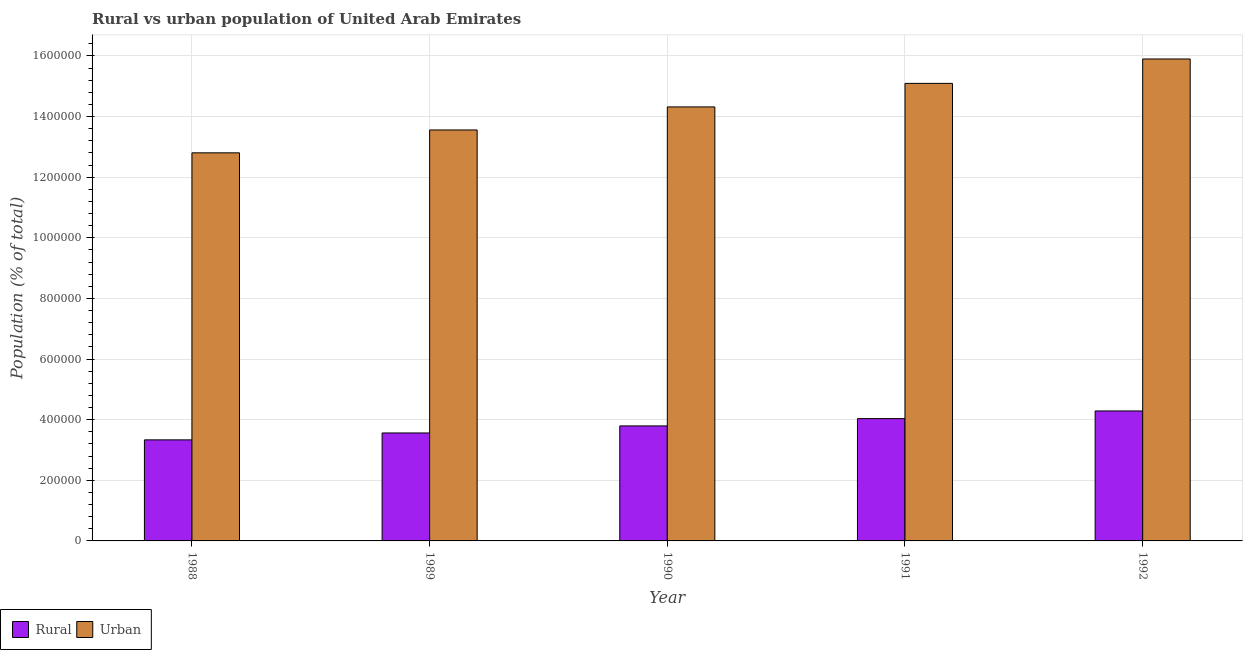How many groups of bars are there?
Ensure brevity in your answer.  5. What is the label of the 5th group of bars from the left?
Your answer should be very brief. 1992. What is the rural population density in 1989?
Keep it short and to the point. 3.56e+05. Across all years, what is the maximum urban population density?
Make the answer very short. 1.59e+06. Across all years, what is the minimum urban population density?
Your answer should be compact. 1.28e+06. In which year was the rural population density maximum?
Give a very brief answer. 1992. In which year was the urban population density minimum?
Make the answer very short. 1988. What is the total rural population density in the graph?
Make the answer very short. 1.90e+06. What is the difference between the urban population density in 1988 and that in 1991?
Provide a short and direct response. -2.29e+05. What is the difference between the urban population density in 1992 and the rural population density in 1989?
Your response must be concise. 2.34e+05. What is the average urban population density per year?
Provide a succinct answer. 1.43e+06. In the year 1991, what is the difference between the urban population density and rural population density?
Your answer should be compact. 0. In how many years, is the rural population density greater than 1480000 %?
Give a very brief answer. 0. What is the ratio of the urban population density in 1989 to that in 1992?
Provide a succinct answer. 0.85. Is the urban population density in 1988 less than that in 1992?
Ensure brevity in your answer.  Yes. What is the difference between the highest and the second highest rural population density?
Offer a terse response. 2.53e+04. What is the difference between the highest and the lowest rural population density?
Offer a terse response. 9.54e+04. What does the 2nd bar from the left in 1991 represents?
Provide a succinct answer. Urban. What does the 2nd bar from the right in 1990 represents?
Your answer should be very brief. Rural. How many bars are there?
Your response must be concise. 10. Does the graph contain grids?
Offer a terse response. Yes. Where does the legend appear in the graph?
Give a very brief answer. Bottom left. How many legend labels are there?
Offer a very short reply. 2. How are the legend labels stacked?
Offer a very short reply. Horizontal. What is the title of the graph?
Give a very brief answer. Rural vs urban population of United Arab Emirates. What is the label or title of the Y-axis?
Provide a short and direct response. Population (% of total). What is the Population (% of total) of Rural in 1988?
Ensure brevity in your answer.  3.33e+05. What is the Population (% of total) of Urban in 1988?
Keep it short and to the point. 1.28e+06. What is the Population (% of total) in Rural in 1989?
Your answer should be compact. 3.56e+05. What is the Population (% of total) of Urban in 1989?
Give a very brief answer. 1.36e+06. What is the Population (% of total) of Rural in 1990?
Offer a very short reply. 3.79e+05. What is the Population (% of total) in Urban in 1990?
Offer a terse response. 1.43e+06. What is the Population (% of total) in Rural in 1991?
Offer a terse response. 4.04e+05. What is the Population (% of total) in Urban in 1991?
Your answer should be compact. 1.51e+06. What is the Population (% of total) of Rural in 1992?
Keep it short and to the point. 4.29e+05. What is the Population (% of total) of Urban in 1992?
Your answer should be compact. 1.59e+06. Across all years, what is the maximum Population (% of total) in Rural?
Your answer should be very brief. 4.29e+05. Across all years, what is the maximum Population (% of total) of Urban?
Give a very brief answer. 1.59e+06. Across all years, what is the minimum Population (% of total) in Rural?
Offer a terse response. 3.33e+05. Across all years, what is the minimum Population (% of total) of Urban?
Ensure brevity in your answer.  1.28e+06. What is the total Population (% of total) of Rural in the graph?
Provide a succinct answer. 1.90e+06. What is the total Population (% of total) in Urban in the graph?
Offer a terse response. 7.17e+06. What is the difference between the Population (% of total) in Rural in 1988 and that in 1989?
Make the answer very short. -2.27e+04. What is the difference between the Population (% of total) in Urban in 1988 and that in 1989?
Keep it short and to the point. -7.55e+04. What is the difference between the Population (% of total) of Rural in 1988 and that in 1990?
Provide a succinct answer. -4.60e+04. What is the difference between the Population (% of total) of Urban in 1988 and that in 1990?
Your answer should be compact. -1.52e+05. What is the difference between the Population (% of total) in Rural in 1988 and that in 1991?
Your answer should be very brief. -7.01e+04. What is the difference between the Population (% of total) of Urban in 1988 and that in 1991?
Your answer should be compact. -2.29e+05. What is the difference between the Population (% of total) of Rural in 1988 and that in 1992?
Ensure brevity in your answer.  -9.54e+04. What is the difference between the Population (% of total) in Urban in 1988 and that in 1992?
Provide a succinct answer. -3.10e+05. What is the difference between the Population (% of total) of Rural in 1989 and that in 1990?
Offer a very short reply. -2.33e+04. What is the difference between the Population (% of total) of Urban in 1989 and that in 1990?
Your response must be concise. -7.60e+04. What is the difference between the Population (% of total) of Rural in 1989 and that in 1991?
Ensure brevity in your answer.  -4.74e+04. What is the difference between the Population (% of total) in Urban in 1989 and that in 1991?
Make the answer very short. -1.54e+05. What is the difference between the Population (% of total) in Rural in 1989 and that in 1992?
Ensure brevity in your answer.  -7.26e+04. What is the difference between the Population (% of total) in Urban in 1989 and that in 1992?
Your answer should be compact. -2.34e+05. What is the difference between the Population (% of total) in Rural in 1990 and that in 1991?
Ensure brevity in your answer.  -2.41e+04. What is the difference between the Population (% of total) in Urban in 1990 and that in 1991?
Ensure brevity in your answer.  -7.76e+04. What is the difference between the Population (% of total) of Rural in 1990 and that in 1992?
Make the answer very short. -4.94e+04. What is the difference between the Population (% of total) in Urban in 1990 and that in 1992?
Give a very brief answer. -1.58e+05. What is the difference between the Population (% of total) of Rural in 1991 and that in 1992?
Provide a short and direct response. -2.53e+04. What is the difference between the Population (% of total) in Urban in 1991 and that in 1992?
Your response must be concise. -8.06e+04. What is the difference between the Population (% of total) of Rural in 1988 and the Population (% of total) of Urban in 1989?
Give a very brief answer. -1.02e+06. What is the difference between the Population (% of total) of Rural in 1988 and the Population (% of total) of Urban in 1990?
Your answer should be compact. -1.10e+06. What is the difference between the Population (% of total) of Rural in 1988 and the Population (% of total) of Urban in 1991?
Keep it short and to the point. -1.18e+06. What is the difference between the Population (% of total) in Rural in 1988 and the Population (% of total) in Urban in 1992?
Provide a succinct answer. -1.26e+06. What is the difference between the Population (% of total) of Rural in 1989 and the Population (% of total) of Urban in 1990?
Give a very brief answer. -1.08e+06. What is the difference between the Population (% of total) in Rural in 1989 and the Population (% of total) in Urban in 1991?
Keep it short and to the point. -1.15e+06. What is the difference between the Population (% of total) of Rural in 1989 and the Population (% of total) of Urban in 1992?
Your response must be concise. -1.23e+06. What is the difference between the Population (% of total) in Rural in 1990 and the Population (% of total) in Urban in 1991?
Make the answer very short. -1.13e+06. What is the difference between the Population (% of total) of Rural in 1990 and the Population (% of total) of Urban in 1992?
Ensure brevity in your answer.  -1.21e+06. What is the difference between the Population (% of total) in Rural in 1991 and the Population (% of total) in Urban in 1992?
Your response must be concise. -1.19e+06. What is the average Population (% of total) in Rural per year?
Your response must be concise. 3.80e+05. What is the average Population (% of total) of Urban per year?
Provide a short and direct response. 1.43e+06. In the year 1988, what is the difference between the Population (% of total) in Rural and Population (% of total) in Urban?
Give a very brief answer. -9.47e+05. In the year 1989, what is the difference between the Population (% of total) in Rural and Population (% of total) in Urban?
Provide a succinct answer. -1.00e+06. In the year 1990, what is the difference between the Population (% of total) of Rural and Population (% of total) of Urban?
Make the answer very short. -1.05e+06. In the year 1991, what is the difference between the Population (% of total) in Rural and Population (% of total) in Urban?
Provide a short and direct response. -1.11e+06. In the year 1992, what is the difference between the Population (% of total) of Rural and Population (% of total) of Urban?
Your answer should be very brief. -1.16e+06. What is the ratio of the Population (% of total) in Rural in 1988 to that in 1989?
Provide a succinct answer. 0.94. What is the ratio of the Population (% of total) of Urban in 1988 to that in 1989?
Your answer should be compact. 0.94. What is the ratio of the Population (% of total) of Rural in 1988 to that in 1990?
Provide a succinct answer. 0.88. What is the ratio of the Population (% of total) of Urban in 1988 to that in 1990?
Make the answer very short. 0.89. What is the ratio of the Population (% of total) in Rural in 1988 to that in 1991?
Keep it short and to the point. 0.83. What is the ratio of the Population (% of total) of Urban in 1988 to that in 1991?
Provide a short and direct response. 0.85. What is the ratio of the Population (% of total) in Rural in 1988 to that in 1992?
Ensure brevity in your answer.  0.78. What is the ratio of the Population (% of total) of Urban in 1988 to that in 1992?
Provide a short and direct response. 0.81. What is the ratio of the Population (% of total) in Rural in 1989 to that in 1990?
Provide a succinct answer. 0.94. What is the ratio of the Population (% of total) of Urban in 1989 to that in 1990?
Keep it short and to the point. 0.95. What is the ratio of the Population (% of total) in Rural in 1989 to that in 1991?
Offer a terse response. 0.88. What is the ratio of the Population (% of total) in Urban in 1989 to that in 1991?
Ensure brevity in your answer.  0.9. What is the ratio of the Population (% of total) in Rural in 1989 to that in 1992?
Ensure brevity in your answer.  0.83. What is the ratio of the Population (% of total) in Urban in 1989 to that in 1992?
Offer a very short reply. 0.85. What is the ratio of the Population (% of total) of Rural in 1990 to that in 1991?
Your response must be concise. 0.94. What is the ratio of the Population (% of total) in Urban in 1990 to that in 1991?
Provide a succinct answer. 0.95. What is the ratio of the Population (% of total) in Rural in 1990 to that in 1992?
Your answer should be very brief. 0.88. What is the ratio of the Population (% of total) in Urban in 1990 to that in 1992?
Offer a very short reply. 0.9. What is the ratio of the Population (% of total) of Rural in 1991 to that in 1992?
Provide a succinct answer. 0.94. What is the ratio of the Population (% of total) of Urban in 1991 to that in 1992?
Ensure brevity in your answer.  0.95. What is the difference between the highest and the second highest Population (% of total) of Rural?
Offer a very short reply. 2.53e+04. What is the difference between the highest and the second highest Population (% of total) in Urban?
Offer a terse response. 8.06e+04. What is the difference between the highest and the lowest Population (% of total) of Rural?
Offer a very short reply. 9.54e+04. What is the difference between the highest and the lowest Population (% of total) in Urban?
Your response must be concise. 3.10e+05. 